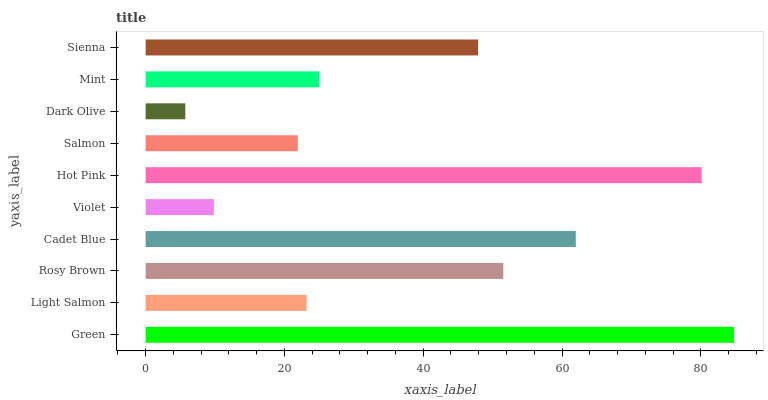Is Dark Olive the minimum?
Answer yes or no. Yes. Is Green the maximum?
Answer yes or no. Yes. Is Light Salmon the minimum?
Answer yes or no. No. Is Light Salmon the maximum?
Answer yes or no. No. Is Green greater than Light Salmon?
Answer yes or no. Yes. Is Light Salmon less than Green?
Answer yes or no. Yes. Is Light Salmon greater than Green?
Answer yes or no. No. Is Green less than Light Salmon?
Answer yes or no. No. Is Sienna the high median?
Answer yes or no. Yes. Is Mint the low median?
Answer yes or no. Yes. Is Light Salmon the high median?
Answer yes or no. No. Is Violet the low median?
Answer yes or no. No. 